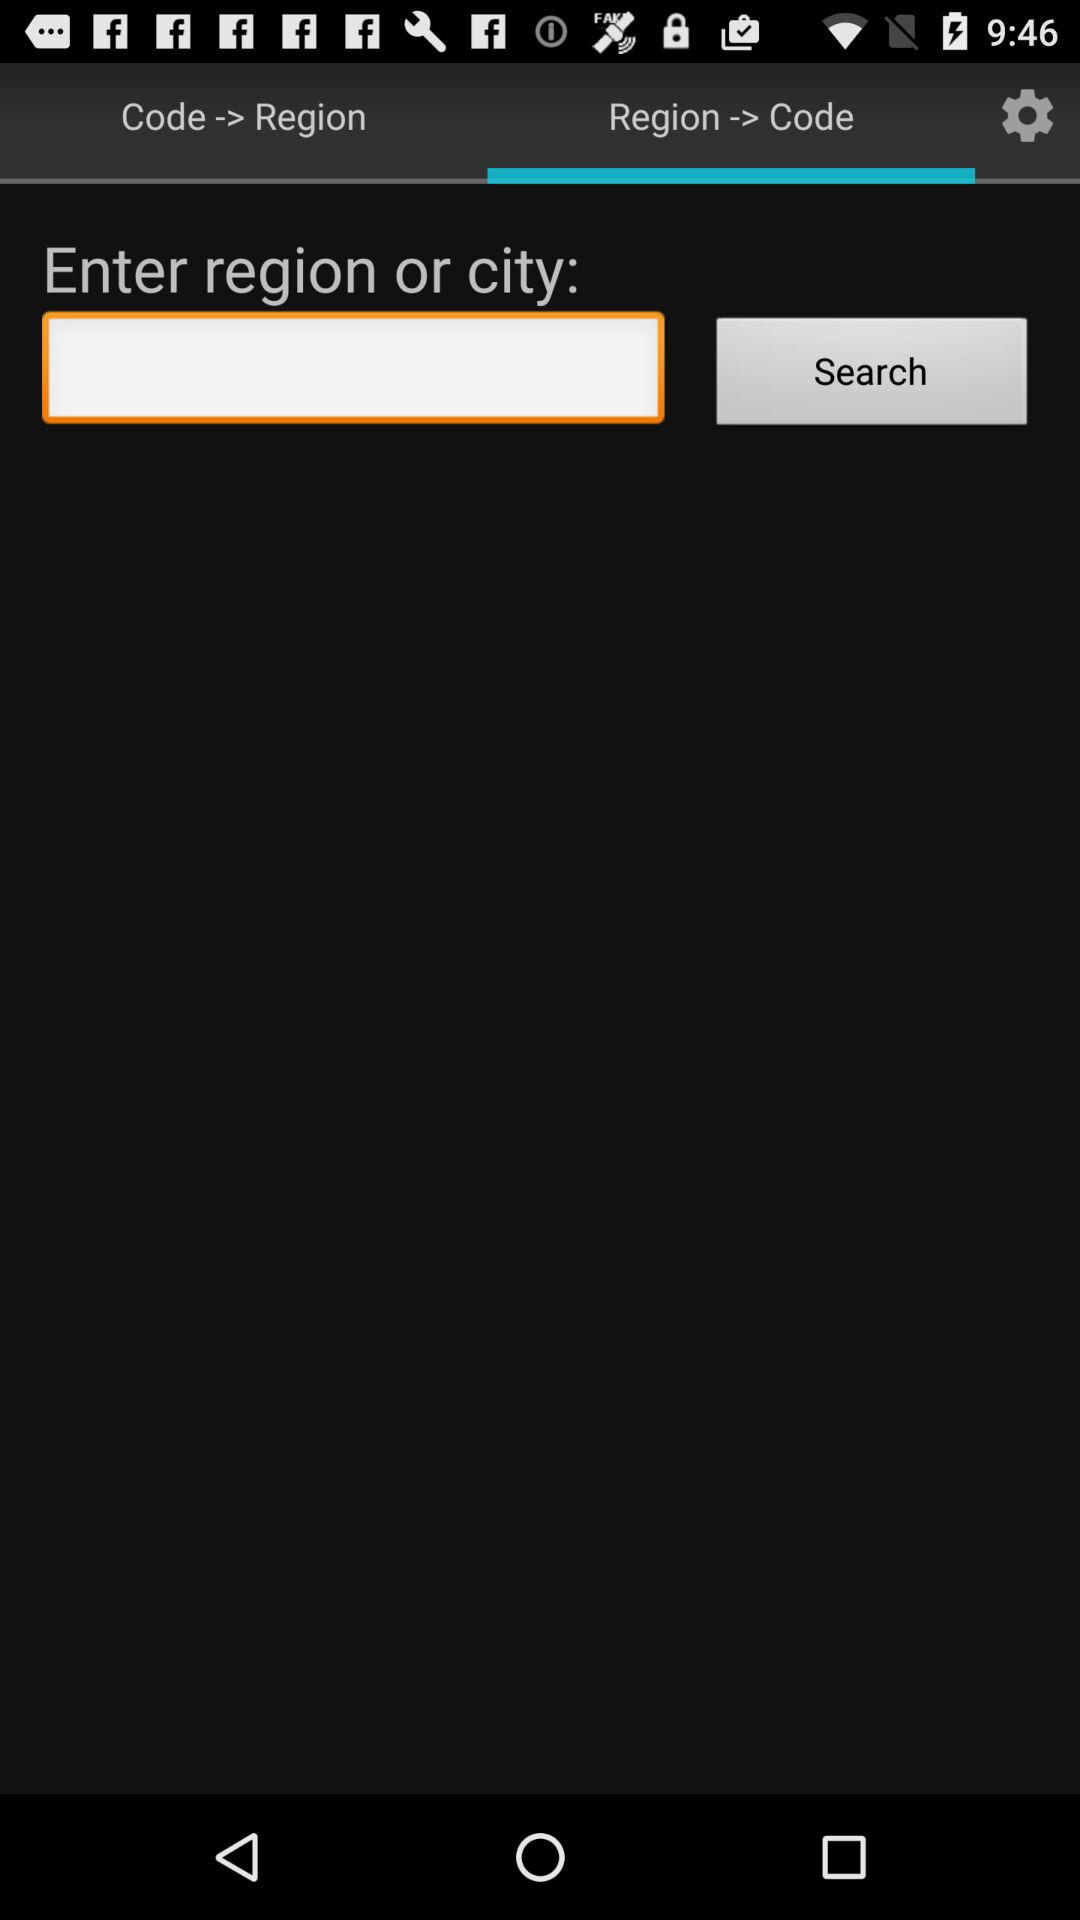Which tab am I using? You are using the tab "Region -> Code". 